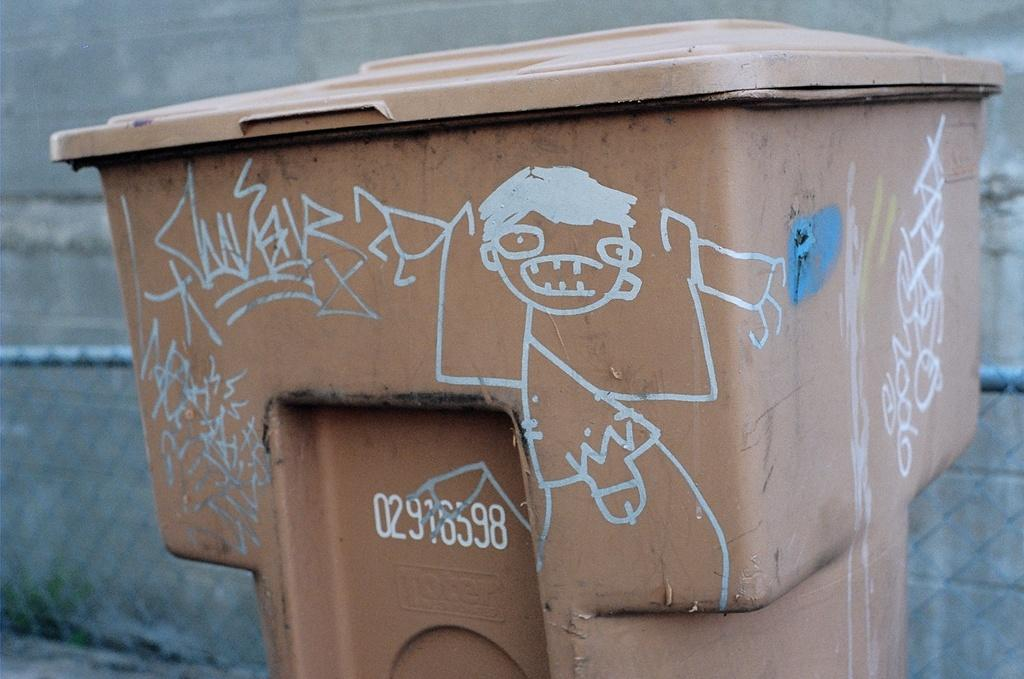<image>
Offer a succinct explanation of the picture presented. Brown garbage with numbers which said 02916598 on it. 